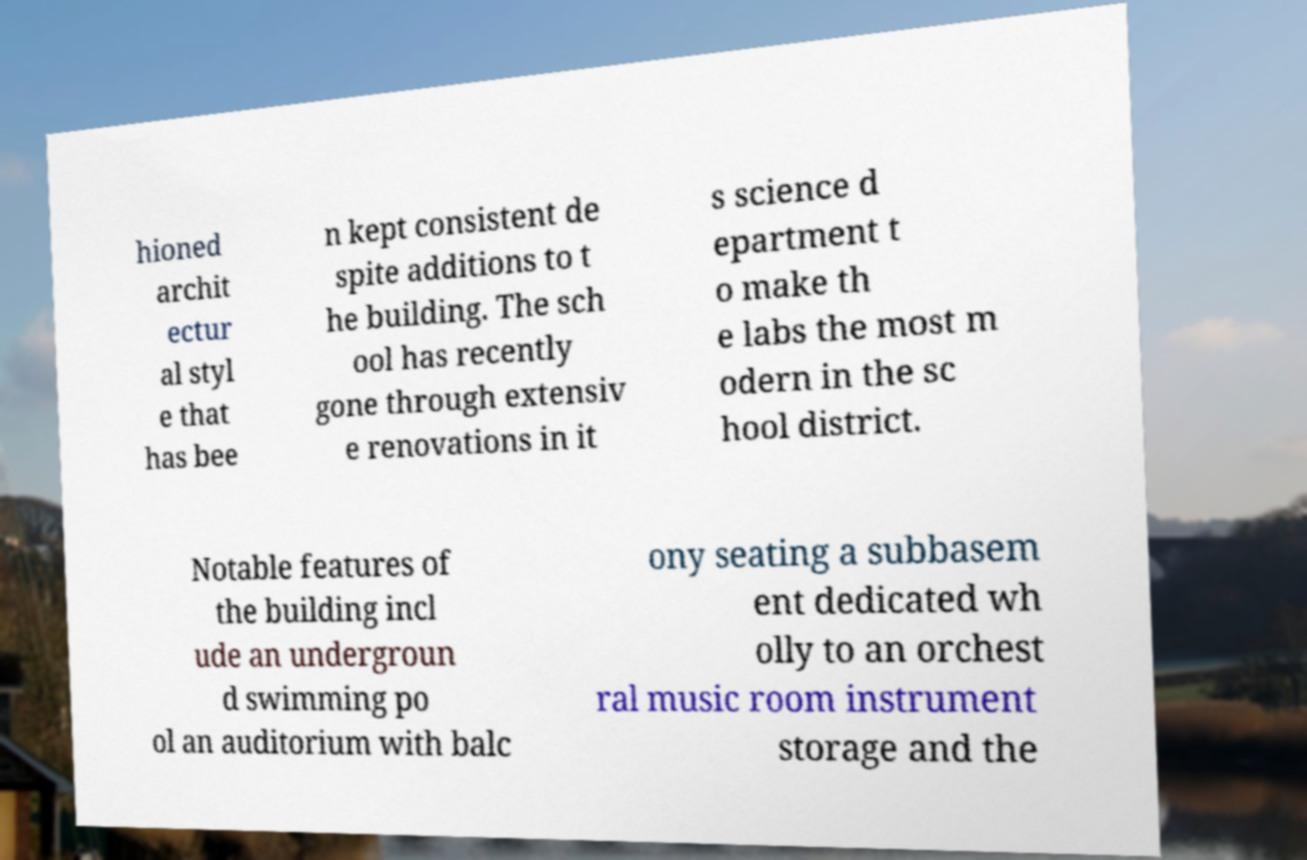I need the written content from this picture converted into text. Can you do that? hioned archit ectur al styl e that has bee n kept consistent de spite additions to t he building. The sch ool has recently gone through extensiv e renovations in it s science d epartment t o make th e labs the most m odern in the sc hool district. Notable features of the building incl ude an undergroun d swimming po ol an auditorium with balc ony seating a subbasem ent dedicated wh olly to an orchest ral music room instrument storage and the 